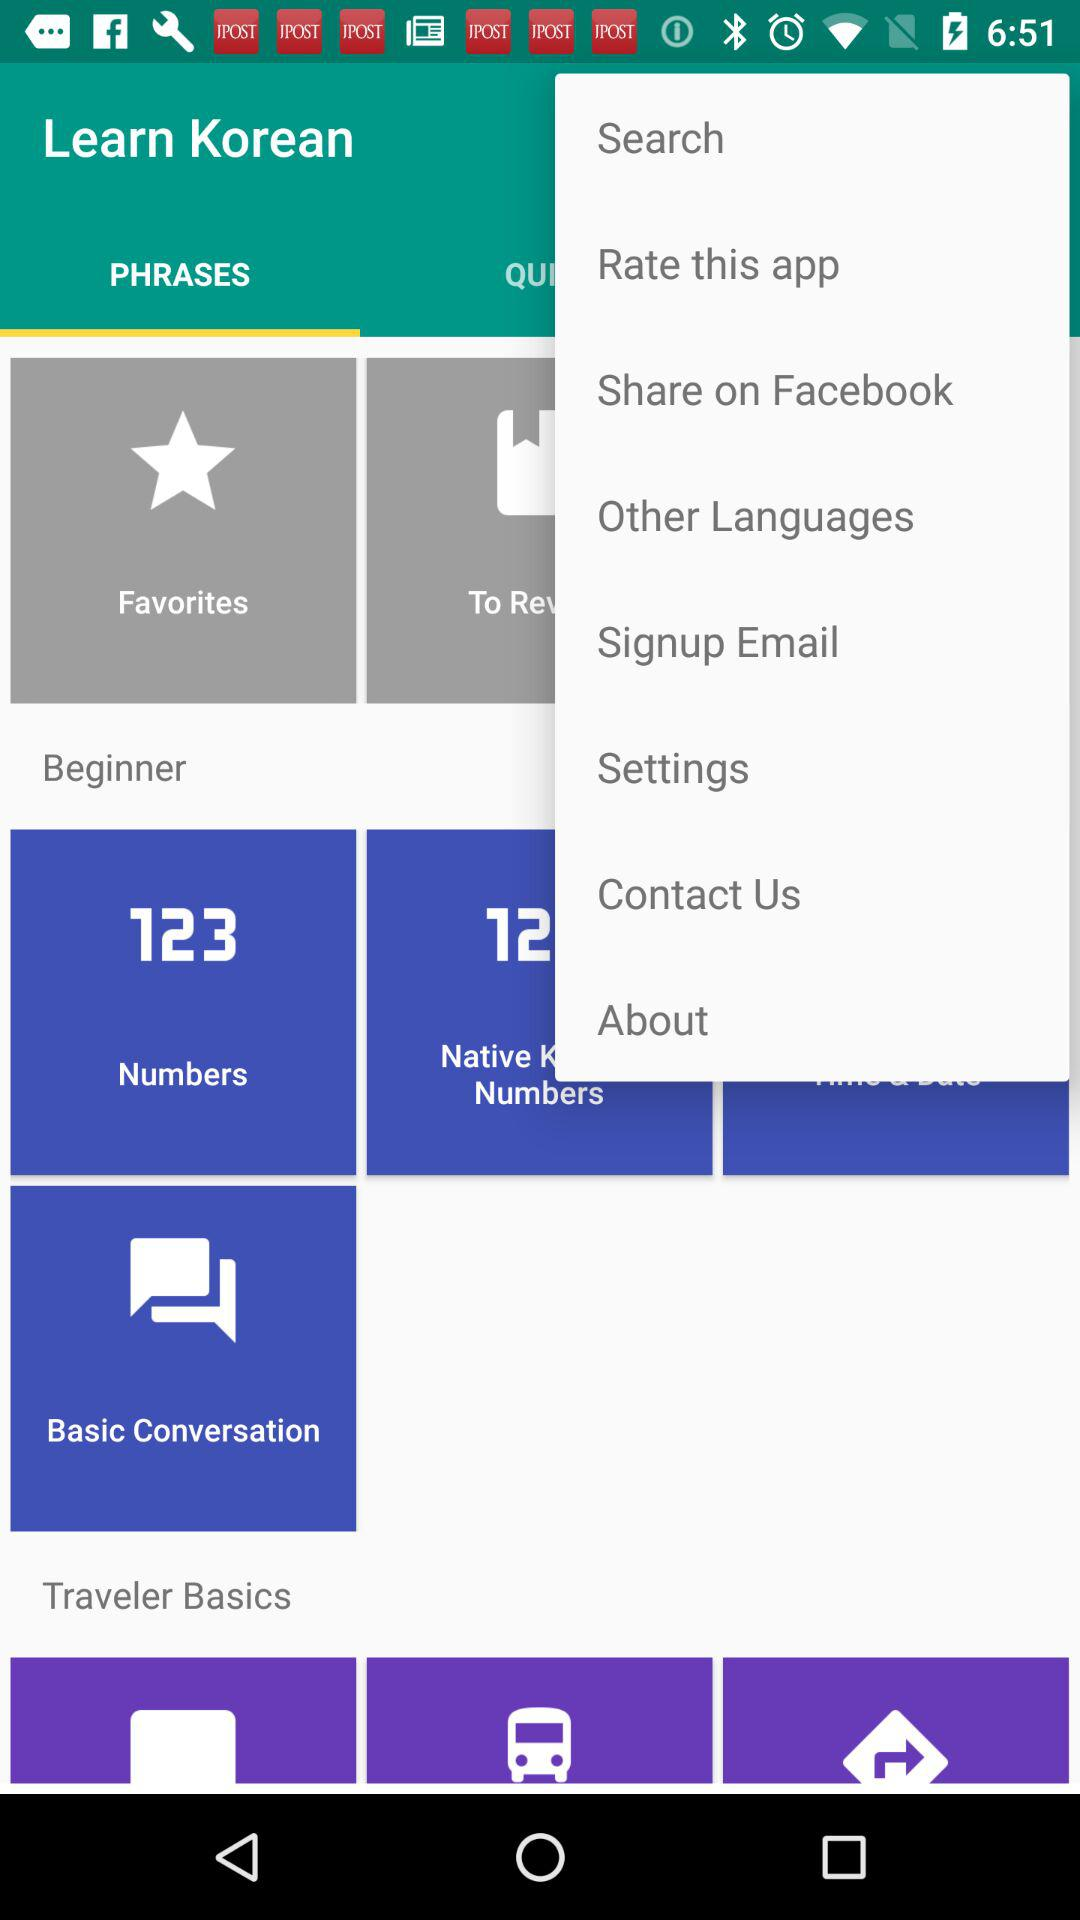Which tab is selected? The selected tab is "PHRASES". 